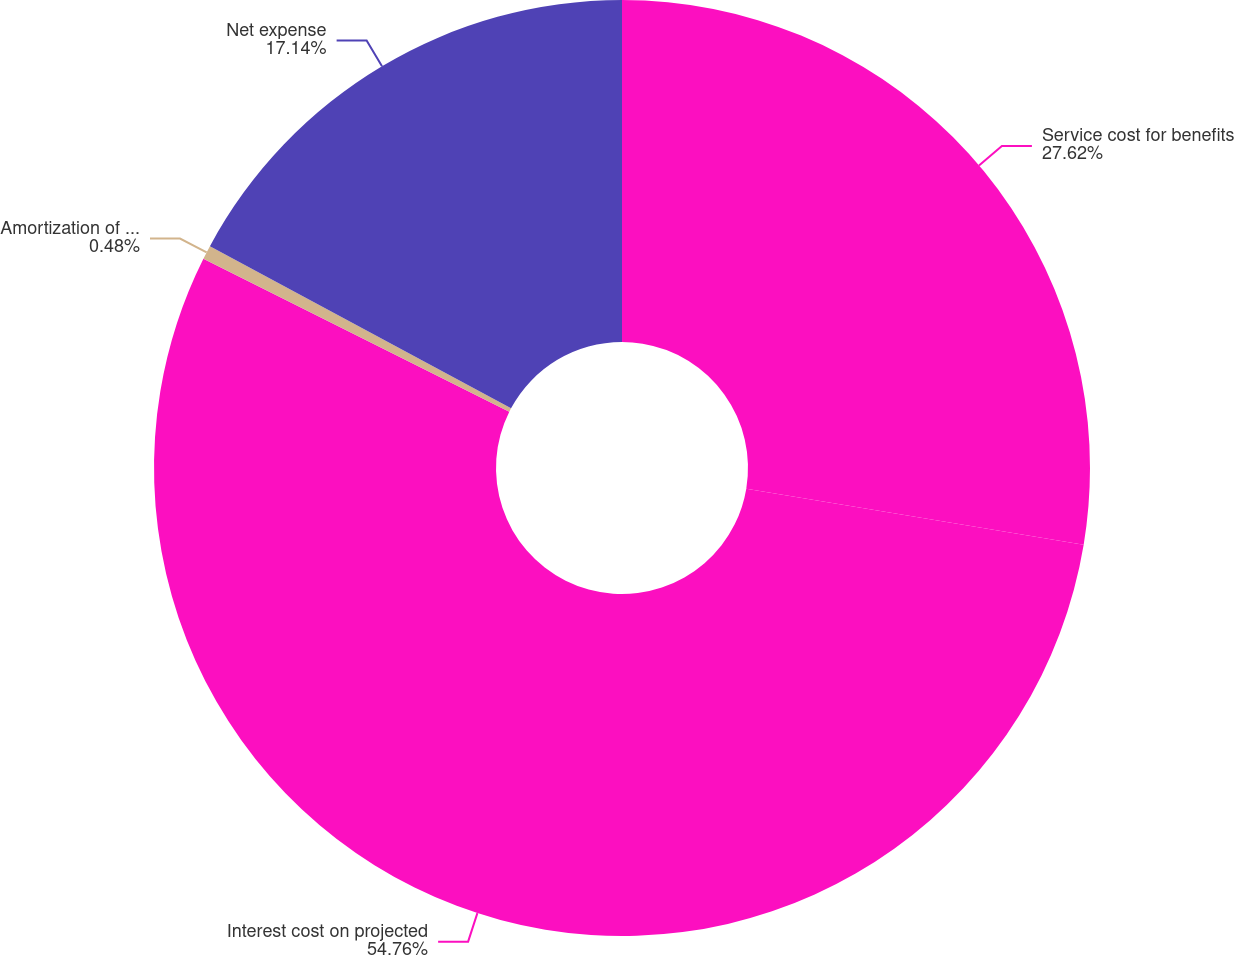Convert chart to OTSL. <chart><loc_0><loc_0><loc_500><loc_500><pie_chart><fcel>Service cost for benefits<fcel>Interest cost on projected<fcel>Amortization of transition<fcel>Net expense<nl><fcel>27.62%<fcel>54.76%<fcel>0.48%<fcel>17.14%<nl></chart> 